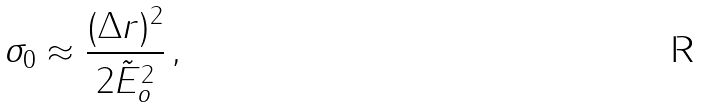Convert formula to latex. <formula><loc_0><loc_0><loc_500><loc_500>\sigma _ { 0 } \approx \frac { ( \Delta r ) ^ { 2 } } { 2 \tilde { E } _ { o } ^ { 2 } } \, ,</formula> 